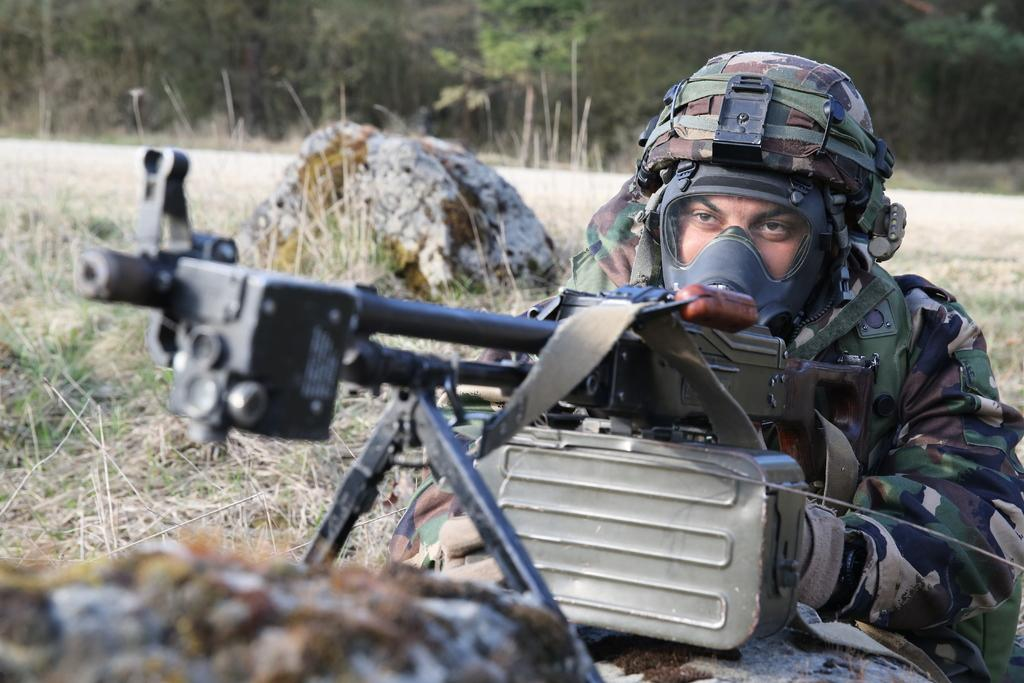What is the main subject of the image? The main subject of the image is an army man. What is the army man doing in the image? The army man is laying on the floor in the image. What is the army man holding in the image? The army man is holding a weapon in the image. What type of clothing is the army man wearing? The army man is wearing an army dress and a cap in the image. What can be seen in the background of the image? There are trees visible in the background of the image. What type of feeling can be seen on the army man's face in the image? The image does not show the army man's face, so it is not possible to determine his feelings. What direction is the army man facing in the image? The image does not provide information about the direction the army man is facing. 